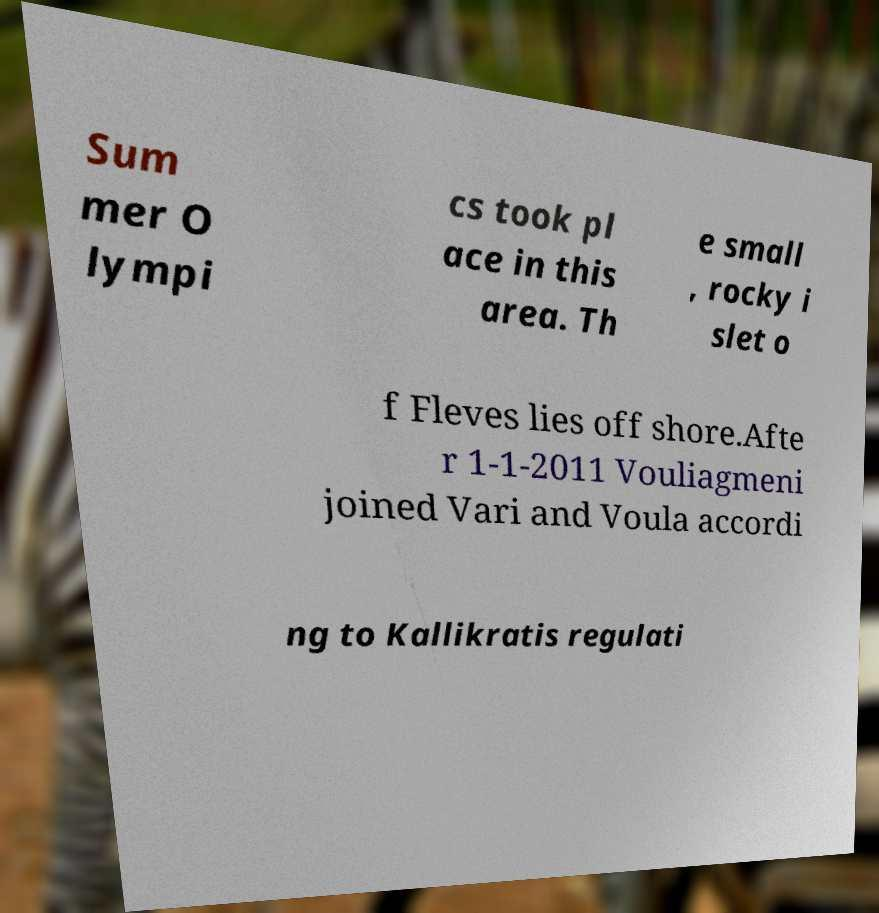Please read and relay the text visible in this image. What does it say? Sum mer O lympi cs took pl ace in this area. Th e small , rocky i slet o f Fleves lies off shore.Afte r 1-1-2011 Vouliagmeni joined Vari and Voula accordi ng to Kallikratis regulati 